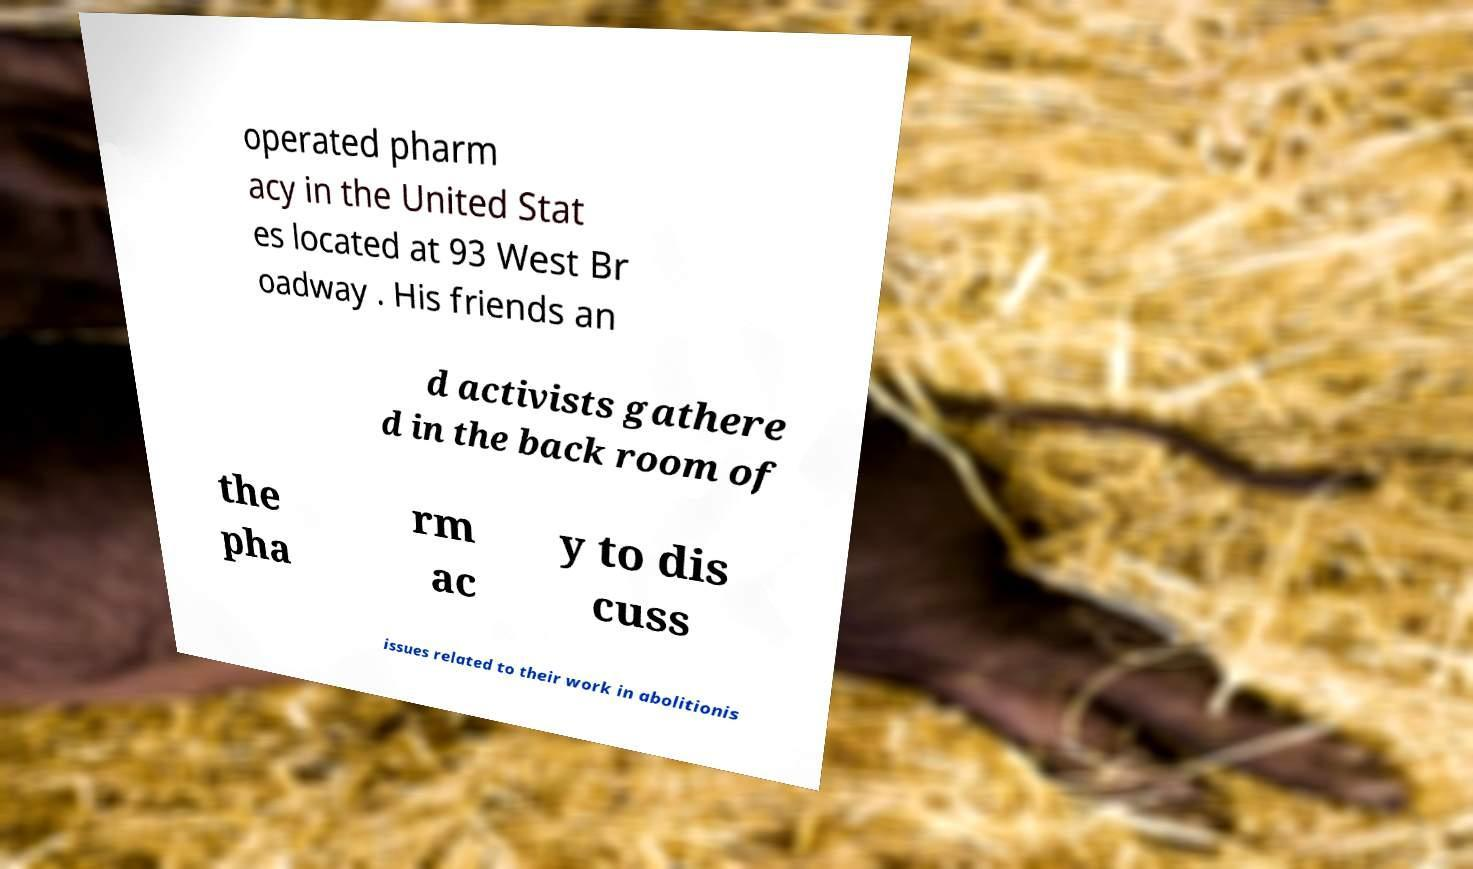For documentation purposes, I need the text within this image transcribed. Could you provide that? operated pharm acy in the United Stat es located at 93 West Br oadway . His friends an d activists gathere d in the back room of the pha rm ac y to dis cuss issues related to their work in abolitionis 